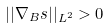<formula> <loc_0><loc_0><loc_500><loc_500>| | \nabla _ { B } s | | _ { L ^ { 2 } } > 0</formula> 